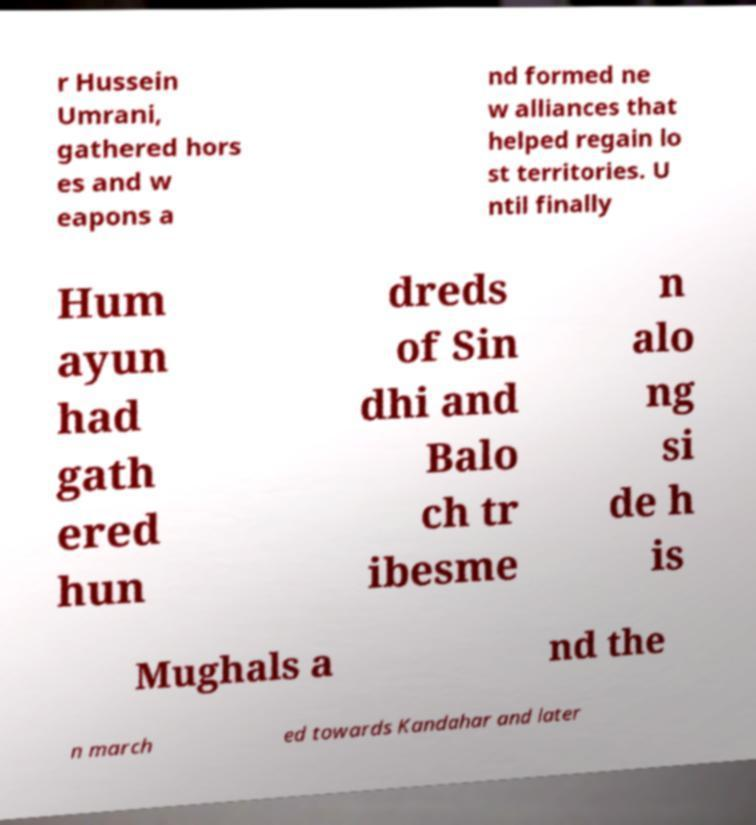I need the written content from this picture converted into text. Can you do that? r Hussein Umrani, gathered hors es and w eapons a nd formed ne w alliances that helped regain lo st territories. U ntil finally Hum ayun had gath ered hun dreds of Sin dhi and Balo ch tr ibesme n alo ng si de h is Mughals a nd the n march ed towards Kandahar and later 